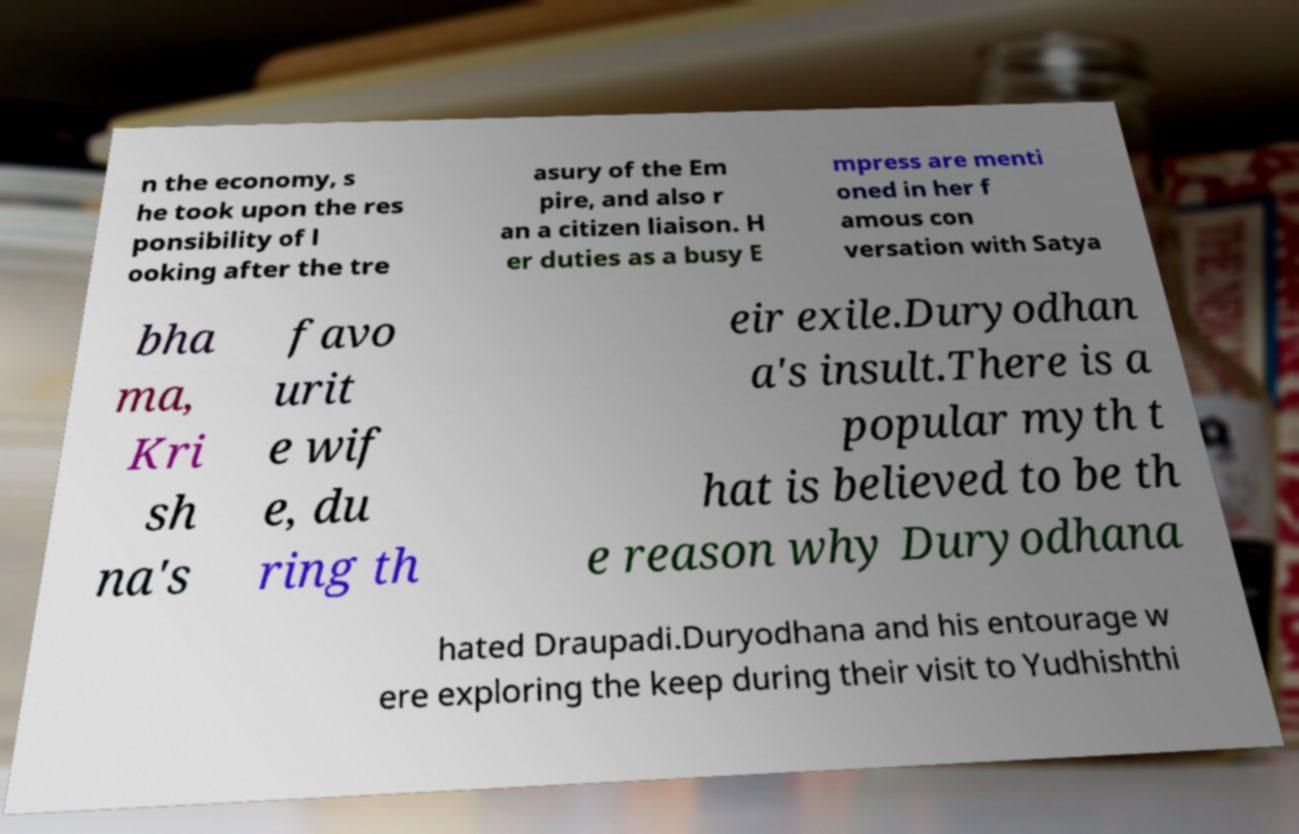Can you read and provide the text displayed in the image?This photo seems to have some interesting text. Can you extract and type it out for me? n the economy, s he took upon the res ponsibility of l ooking after the tre asury of the Em pire, and also r an a citizen liaison. H er duties as a busy E mpress are menti oned in her f amous con versation with Satya bha ma, Kri sh na's favo urit e wif e, du ring th eir exile.Duryodhan a's insult.There is a popular myth t hat is believed to be th e reason why Duryodhana hated Draupadi.Duryodhana and his entourage w ere exploring the keep during their visit to Yudhishthi 